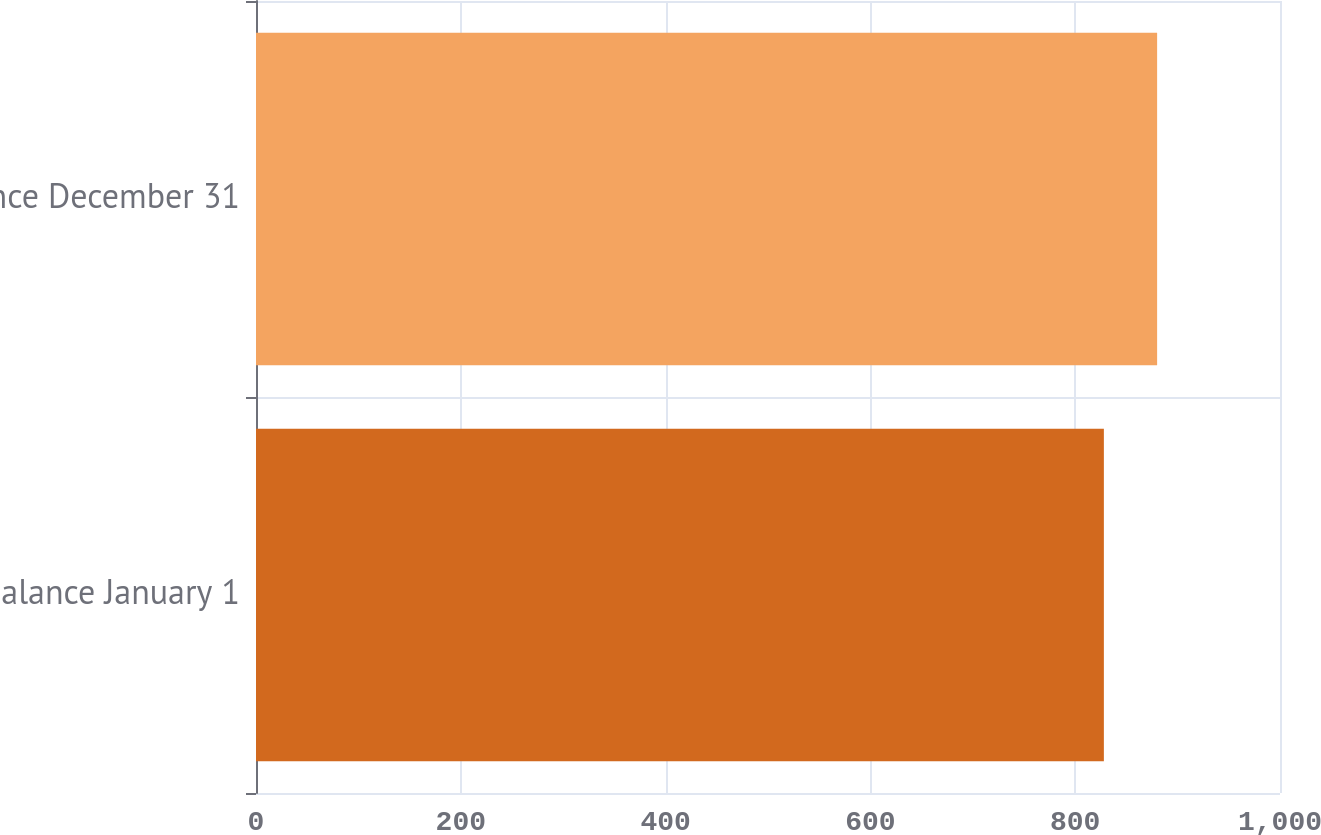<chart> <loc_0><loc_0><loc_500><loc_500><bar_chart><fcel>Balance January 1<fcel>Balance December 31<nl><fcel>828<fcel>880<nl></chart> 